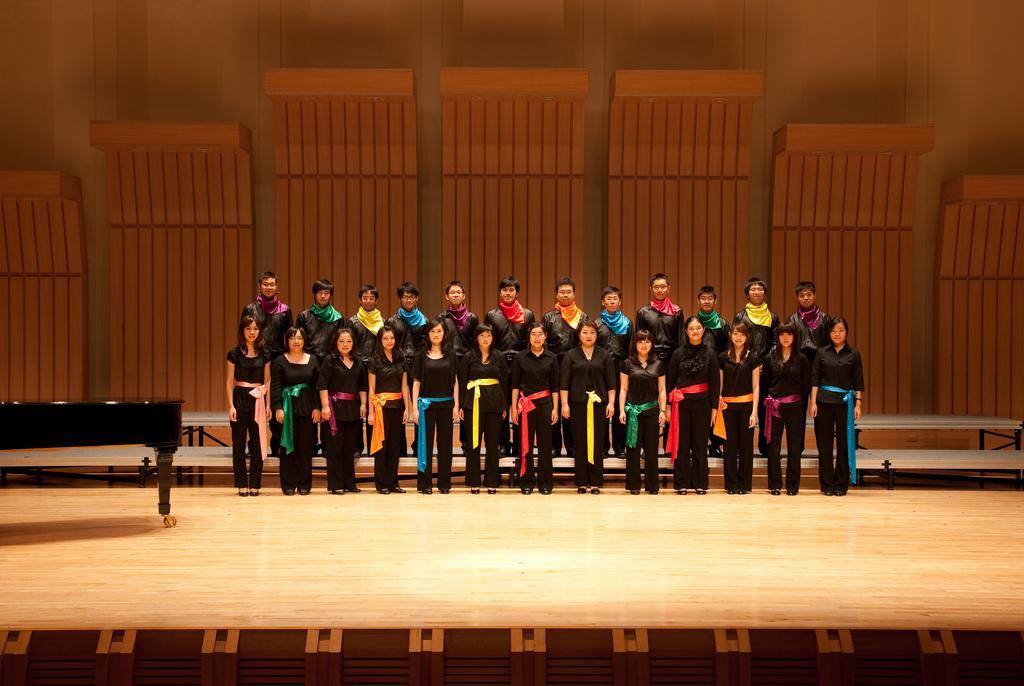Describe this image in one or two sentences. This picture is clicked inside. In the center we can see the group of people standing on the ground. On the left there is a black color table placed on the ground. In the background we can see the wooden objects and the wall. 